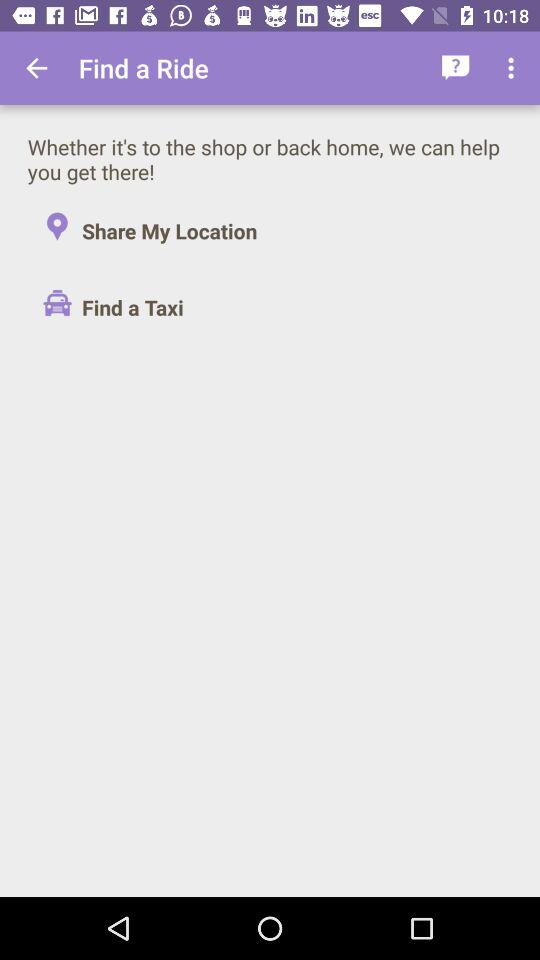What is the user's location?
When the provided information is insufficient, respond with <no answer>. <no answer> 